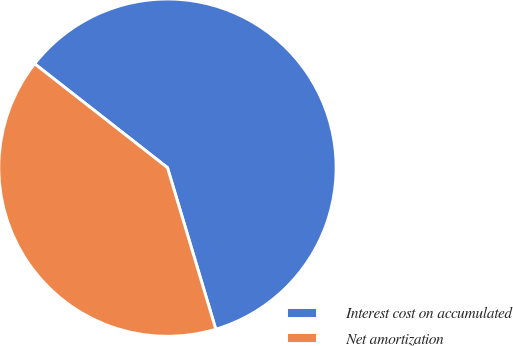Convert chart to OTSL. <chart><loc_0><loc_0><loc_500><loc_500><pie_chart><fcel>Interest cost on accumulated<fcel>Net amortization<nl><fcel>59.81%<fcel>40.19%<nl></chart> 